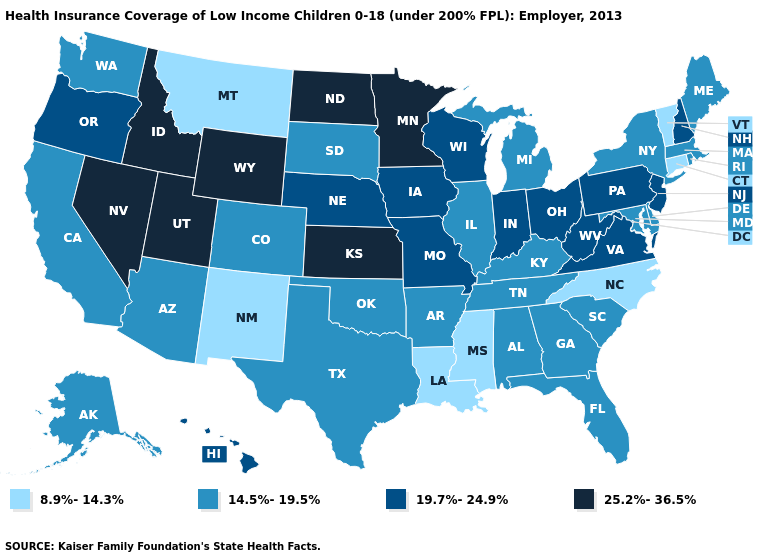Does Hawaii have the lowest value in the West?
Be succinct. No. Name the states that have a value in the range 14.5%-19.5%?
Give a very brief answer. Alabama, Alaska, Arizona, Arkansas, California, Colorado, Delaware, Florida, Georgia, Illinois, Kentucky, Maine, Maryland, Massachusetts, Michigan, New York, Oklahoma, Rhode Island, South Carolina, South Dakota, Tennessee, Texas, Washington. What is the value of Alaska?
Write a very short answer. 14.5%-19.5%. What is the highest value in states that border Iowa?
Short answer required. 25.2%-36.5%. What is the value of Minnesota?
Answer briefly. 25.2%-36.5%. What is the highest value in states that border Missouri?
Give a very brief answer. 25.2%-36.5%. What is the value of Nebraska?
Answer briefly. 19.7%-24.9%. How many symbols are there in the legend?
Write a very short answer. 4. Name the states that have a value in the range 25.2%-36.5%?
Be succinct. Idaho, Kansas, Minnesota, Nevada, North Dakota, Utah, Wyoming. Does Montana have the lowest value in the USA?
Quick response, please. Yes. Does Georgia have the lowest value in the South?
Give a very brief answer. No. Does North Carolina have a higher value than Mississippi?
Give a very brief answer. No. Does the map have missing data?
Short answer required. No. How many symbols are there in the legend?
Short answer required. 4. Name the states that have a value in the range 8.9%-14.3%?
Quick response, please. Connecticut, Louisiana, Mississippi, Montana, New Mexico, North Carolina, Vermont. 